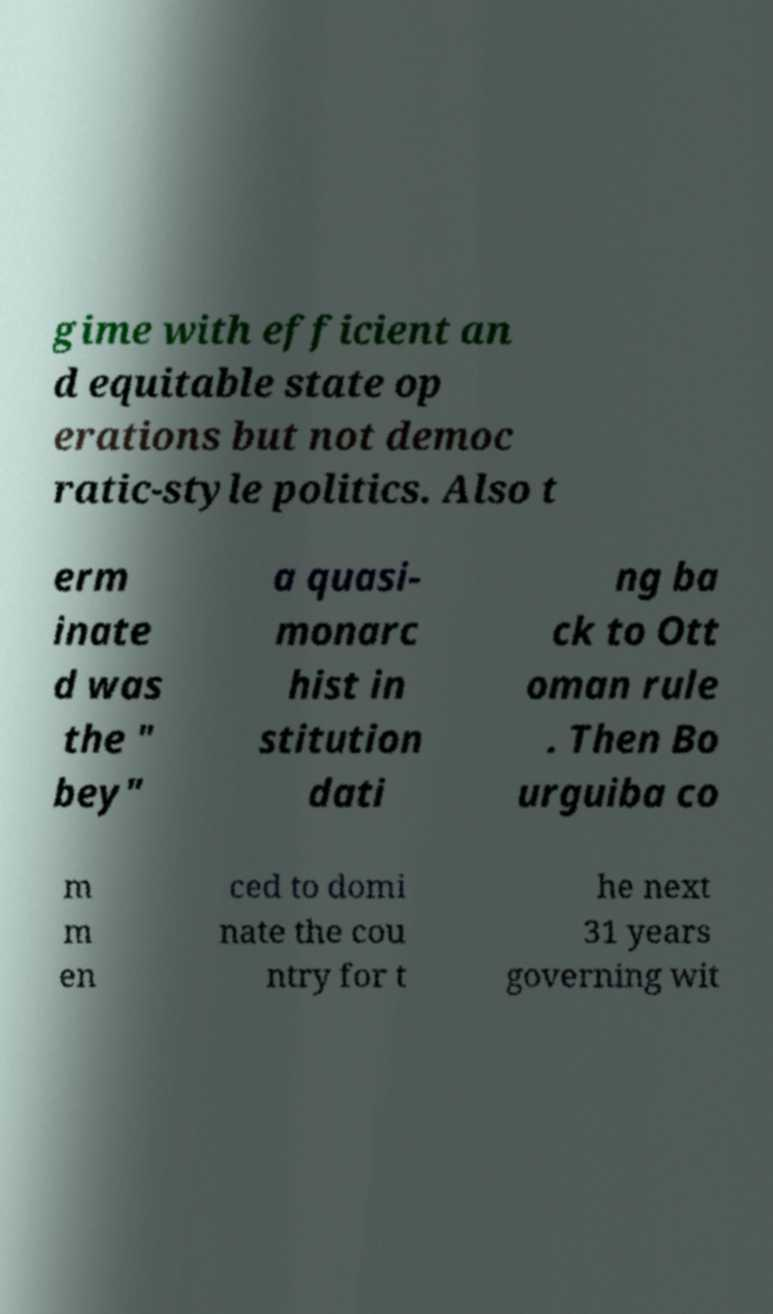Could you extract and type out the text from this image? gime with efficient an d equitable state op erations but not democ ratic-style politics. Also t erm inate d was the " bey" a quasi- monarc hist in stitution dati ng ba ck to Ott oman rule . Then Bo urguiba co m m en ced to domi nate the cou ntry for t he next 31 years governing wit 